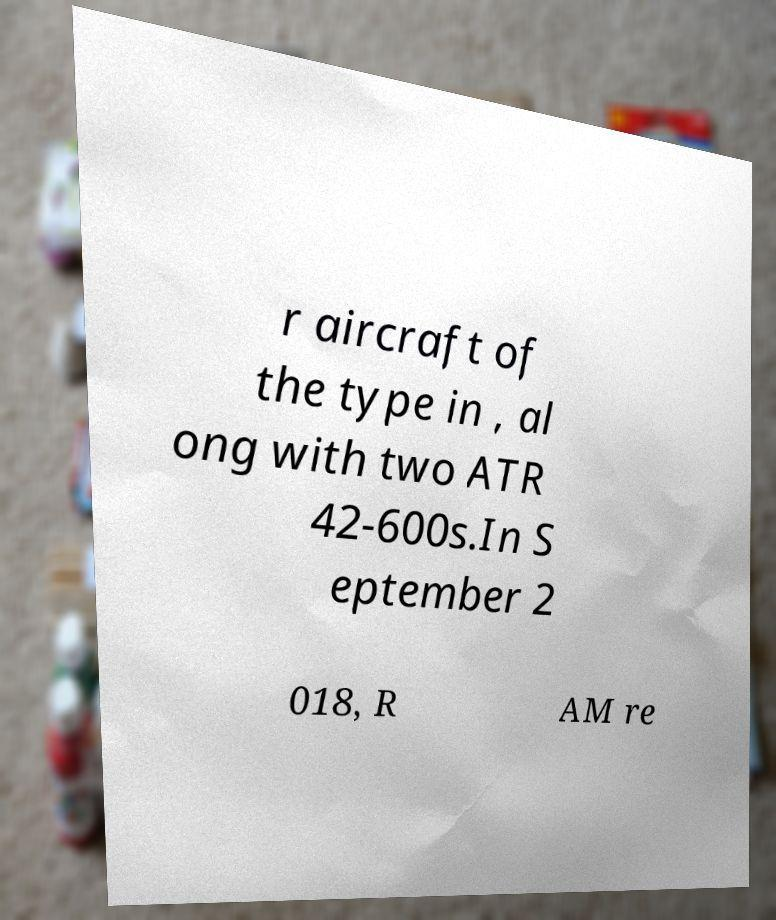Could you extract and type out the text from this image? r aircraft of the type in , al ong with two ATR 42-600s.In S eptember 2 018, R AM re 